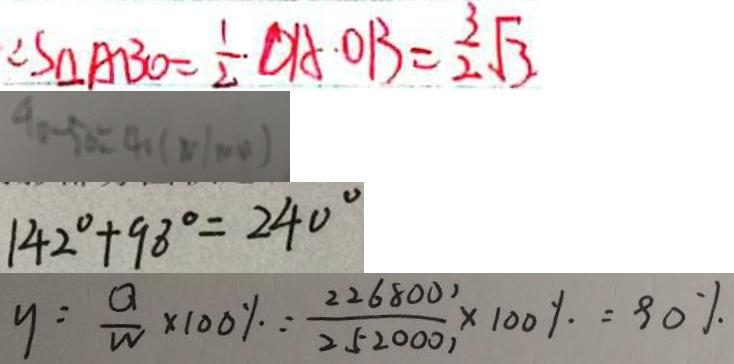<formula> <loc_0><loc_0><loc_500><loc_500>\therefore S _ { \Delta } A B O = \frac { 1 } { 2 } \cdot D A \cdot O B = \frac { 3 } { 2 } \sqrt { 3 } . 
 9 0 - 5 0 = 4 0 ( m / \min ) 
 1 4 2 ^ { \circ } + 9 8 ^ { \circ } = 2 4 0 ^ { \circ } 
 y = \frac { Q } { W } \times 1 0 0 \% \because \frac { 2 2 6 8 0 0 1 } { 2 5 2 0 0 0 1 } \times 1 0 0 \% = 9 0 \%</formula> 